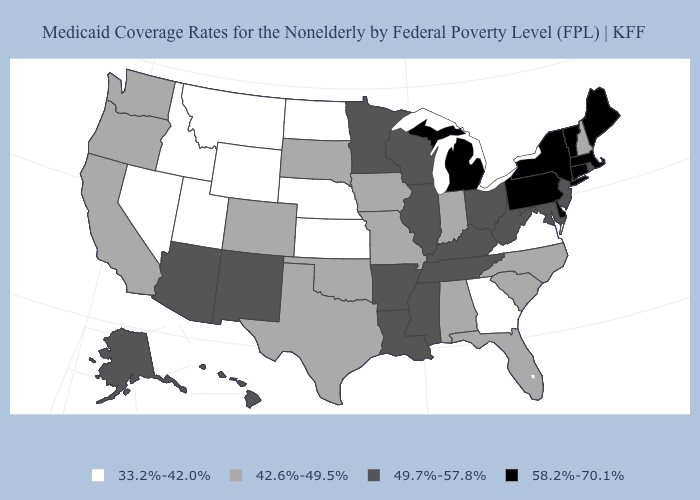What is the value of Rhode Island?
Give a very brief answer. 49.7%-57.8%. Among the states that border Delaware , which have the lowest value?
Answer briefly. Maryland, New Jersey. What is the lowest value in states that border North Carolina?
Short answer required. 33.2%-42.0%. Does Pennsylvania have a lower value than Arkansas?
Quick response, please. No. What is the value of New York?
Be succinct. 58.2%-70.1%. What is the value of Tennessee?
Keep it brief. 49.7%-57.8%. Does New Mexico have the highest value in the West?
Give a very brief answer. Yes. What is the lowest value in the USA?
Concise answer only. 33.2%-42.0%. What is the highest value in the South ?
Concise answer only. 58.2%-70.1%. Among the states that border Alabama , which have the highest value?
Write a very short answer. Mississippi, Tennessee. How many symbols are there in the legend?
Give a very brief answer. 4. Name the states that have a value in the range 33.2%-42.0%?
Concise answer only. Georgia, Idaho, Kansas, Montana, Nebraska, Nevada, North Dakota, Utah, Virginia, Wyoming. Name the states that have a value in the range 42.6%-49.5%?
Write a very short answer. Alabama, California, Colorado, Florida, Indiana, Iowa, Missouri, New Hampshire, North Carolina, Oklahoma, Oregon, South Carolina, South Dakota, Texas, Washington. Name the states that have a value in the range 49.7%-57.8%?
Quick response, please. Alaska, Arizona, Arkansas, Hawaii, Illinois, Kentucky, Louisiana, Maryland, Minnesota, Mississippi, New Jersey, New Mexico, Ohio, Rhode Island, Tennessee, West Virginia, Wisconsin. 